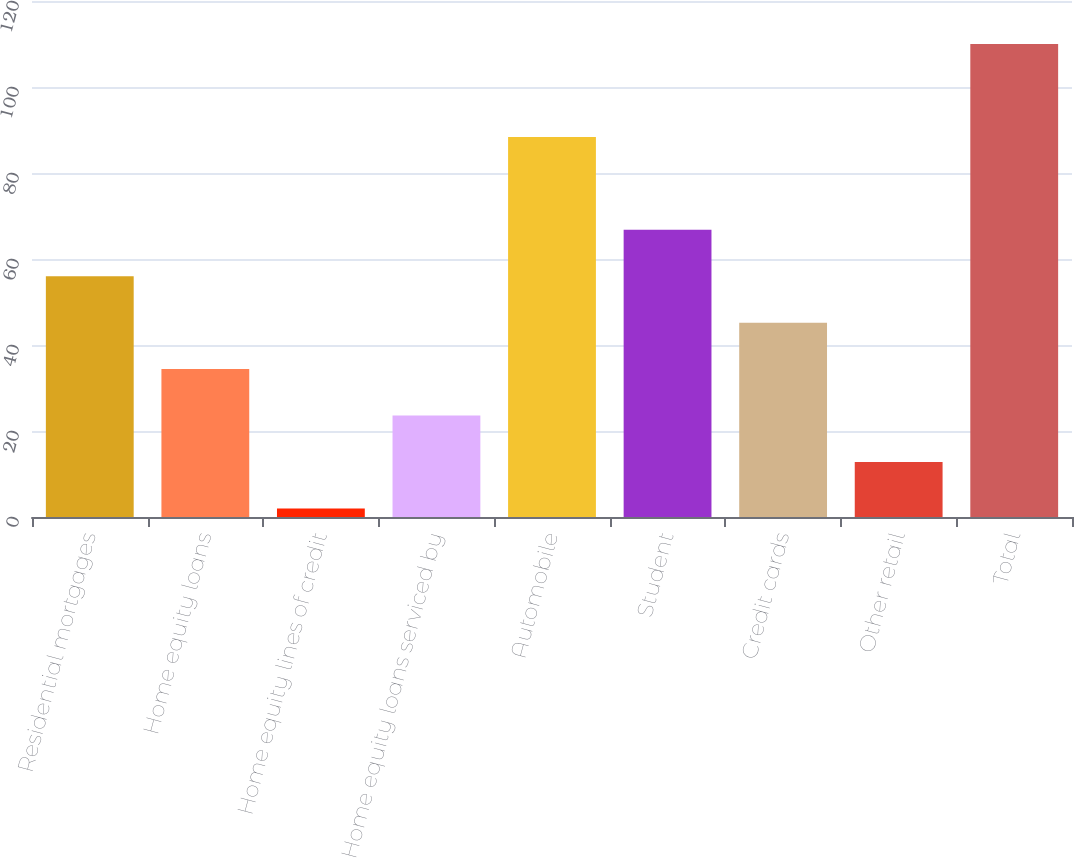Convert chart. <chart><loc_0><loc_0><loc_500><loc_500><bar_chart><fcel>Residential mortgages<fcel>Home equity loans<fcel>Home equity lines of credit<fcel>Home equity loans serviced by<fcel>Automobile<fcel>Student<fcel>Credit cards<fcel>Other retail<fcel>Total<nl><fcel>56<fcel>34.4<fcel>2<fcel>23.6<fcel>88.4<fcel>66.8<fcel>45.2<fcel>12.8<fcel>110<nl></chart> 